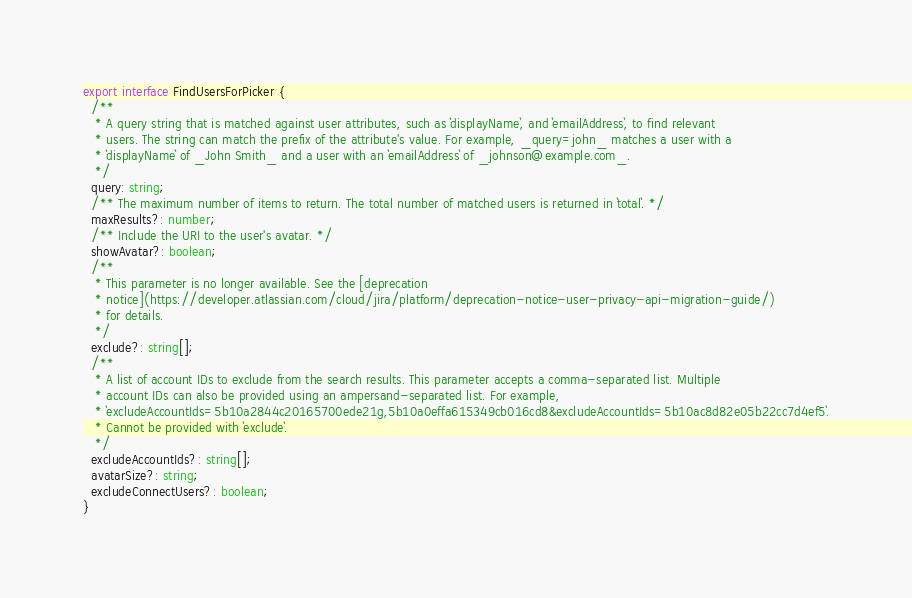Convert code to text. <code><loc_0><loc_0><loc_500><loc_500><_TypeScript_>export interface FindUsersForPicker {
  /**
   * A query string that is matched against user attributes, such as `displayName`, and `emailAddress`, to find relevant
   * users. The string can match the prefix of the attribute's value. For example, _query=john_ matches a user with a
   * `displayName` of _John Smith_ and a user with an `emailAddress` of _johnson@example.com_.
   */
  query: string;
  /** The maximum number of items to return. The total number of matched users is returned in `total`. */
  maxResults?: number;
  /** Include the URI to the user's avatar. */
  showAvatar?: boolean;
  /**
   * This parameter is no longer available. See the [deprecation
   * notice](https://developer.atlassian.com/cloud/jira/platform/deprecation-notice-user-privacy-api-migration-guide/)
   * for details.
   */
  exclude?: string[];
  /**
   * A list of account IDs to exclude from the search results. This parameter accepts a comma-separated list. Multiple
   * account IDs can also be provided using an ampersand-separated list. For example,
   * `excludeAccountIds=5b10a2844c20165700ede21g,5b10a0effa615349cb016cd8&excludeAccountIds=5b10ac8d82e05b22cc7d4ef5`.
   * Cannot be provided with `exclude`.
   */
  excludeAccountIds?: string[];
  avatarSize?: string;
  excludeConnectUsers?: boolean;
}
</code> 